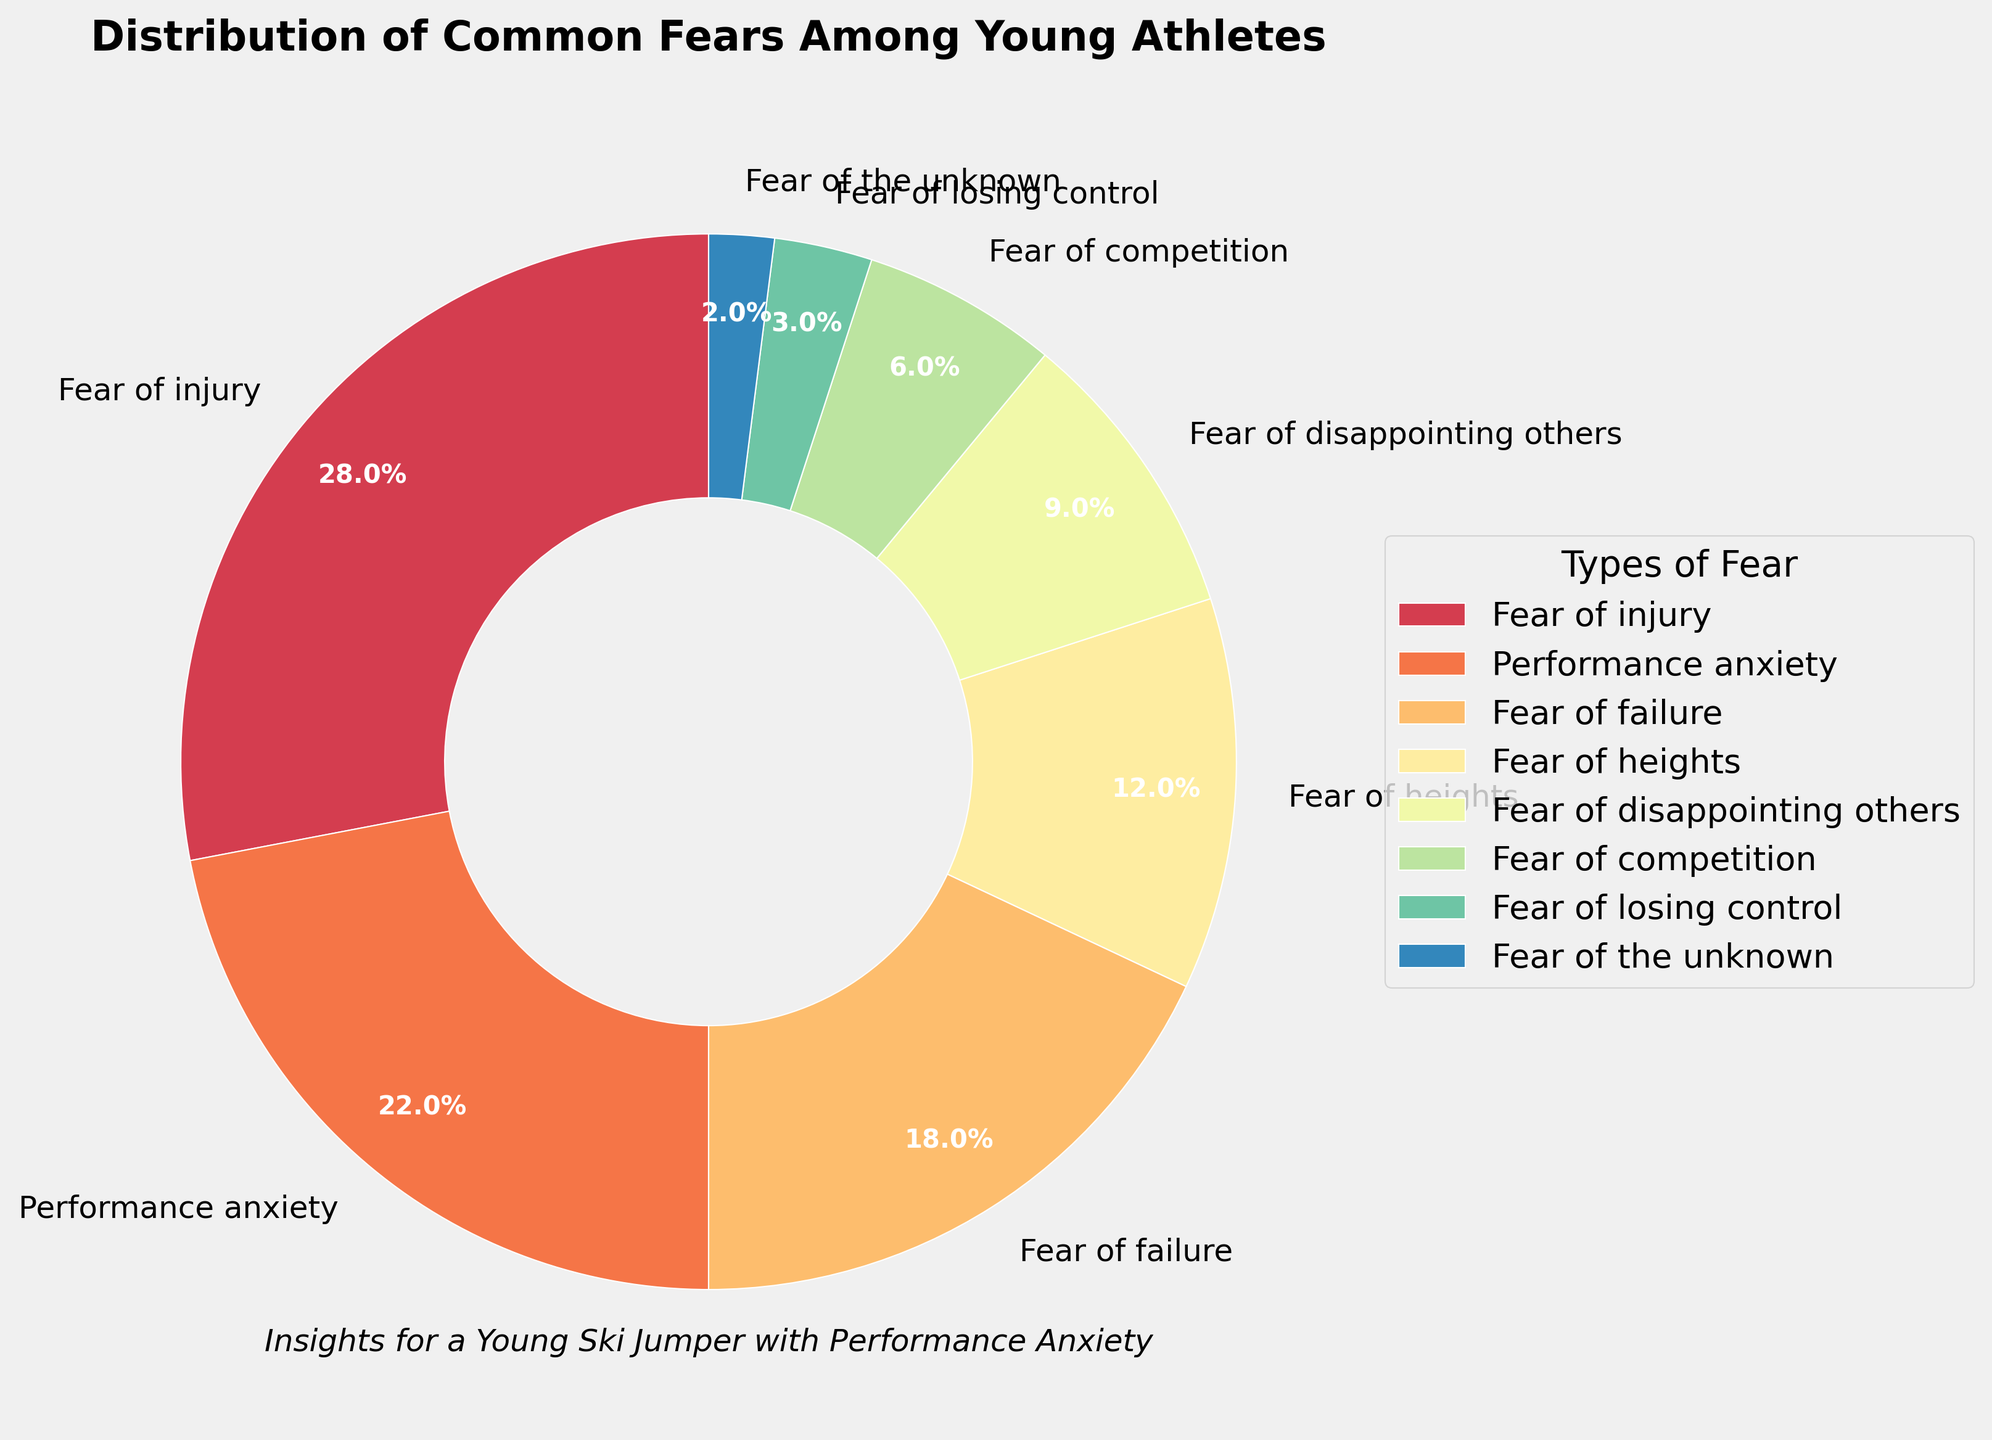What is the fear type with the highest percentage among young athletes? The wedge in the pie chart representing the "Fear of injury" occupies the largest portion of the chart, indicating that it has the highest percentage among the fear types.
Answer: Fear of injury What is the total percentage of young athletes who experience either performance anxiety or fear of failure? The percentage of young athletes who experience performance anxiety is 22% and those who experience fear of failure is 18%. Adding these two percentages gives 22 + 18 = 40%.
Answer: 40% Which fear type is represented with the smallest wedge in the pie chart? The smallest wedge in the pie chart represents "Fear of the unknown," which has the smallest percentage.
Answer: Fear of the unknown How much greater is the percentage of athletes with fear of injury compared to those with fear of heights? The percentage of athletes with fear of injury is 28%, and the percentage with fear of heights is 12%. Subtracting these two percentages gives 28 - 12 = 16%.
Answer: 16% What is the combined percentage of athletes who have fear of competition and fear of losing control? The percentage of athletes with fear of competition is 6%, and the percentage with fear of losing control is 3%. Adding these two percentages gives 6 + 3 = 9%.
Answer: 9% How many fear types have a percentage greater than 20%? The fear types with percentages greater than 20% are "Fear of injury" (28%) and "Performance anxiety" (22%). This results in 2 fear types.
Answer: 2 Arrange the top three fear types in descending order of their percentages. The top three fear types can be arranged in descending order by their percentages: "Fear of injury" (28%), "Performance anxiety" (22%), and "Fear of failure" (18%).
Answer: Fear of injury, Performance anxiety, Fear of failure By how many percentage points does the fear of disappointing others exceed the fear of the unknown? The percentage of athletes with fear of disappointing others is 9%, and the percentage with fear of the unknown is 2%. Subtracting these two percentages gives 9 - 2 = 7%.
Answer: 7% Which fear types are represented in the pie chart by similarly sized wedges? Comparing the sizes of the wedges visually, the wedges representing "Fear of disappointing others" (9%) and "Fear of competition" (6%) appear similarly sized, although the exact percentages are not identical.
Answer: Fear of disappointing others, Fear of competition 